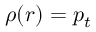<formula> <loc_0><loc_0><loc_500><loc_500>\rho ( r ) = p _ { t }</formula> 